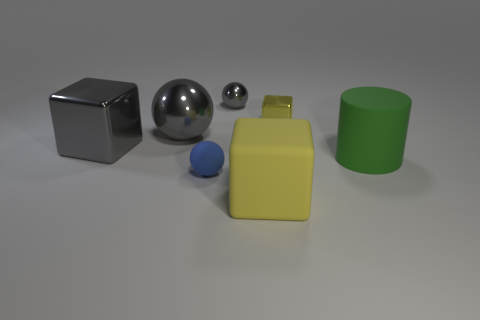Subtract all gray cylinders. How many gray spheres are left? 2 Subtract all big metallic cubes. How many cubes are left? 2 Add 3 small blue rubber spheres. How many objects exist? 10 Subtract all cylinders. How many objects are left? 6 Subtract all big green things. Subtract all big cylinders. How many objects are left? 5 Add 5 gray balls. How many gray balls are left? 7 Add 7 yellow shiny objects. How many yellow shiny objects exist? 8 Subtract 1 blue spheres. How many objects are left? 6 